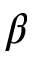Convert formula to latex. <formula><loc_0><loc_0><loc_500><loc_500>\beta \hbar</formula> 